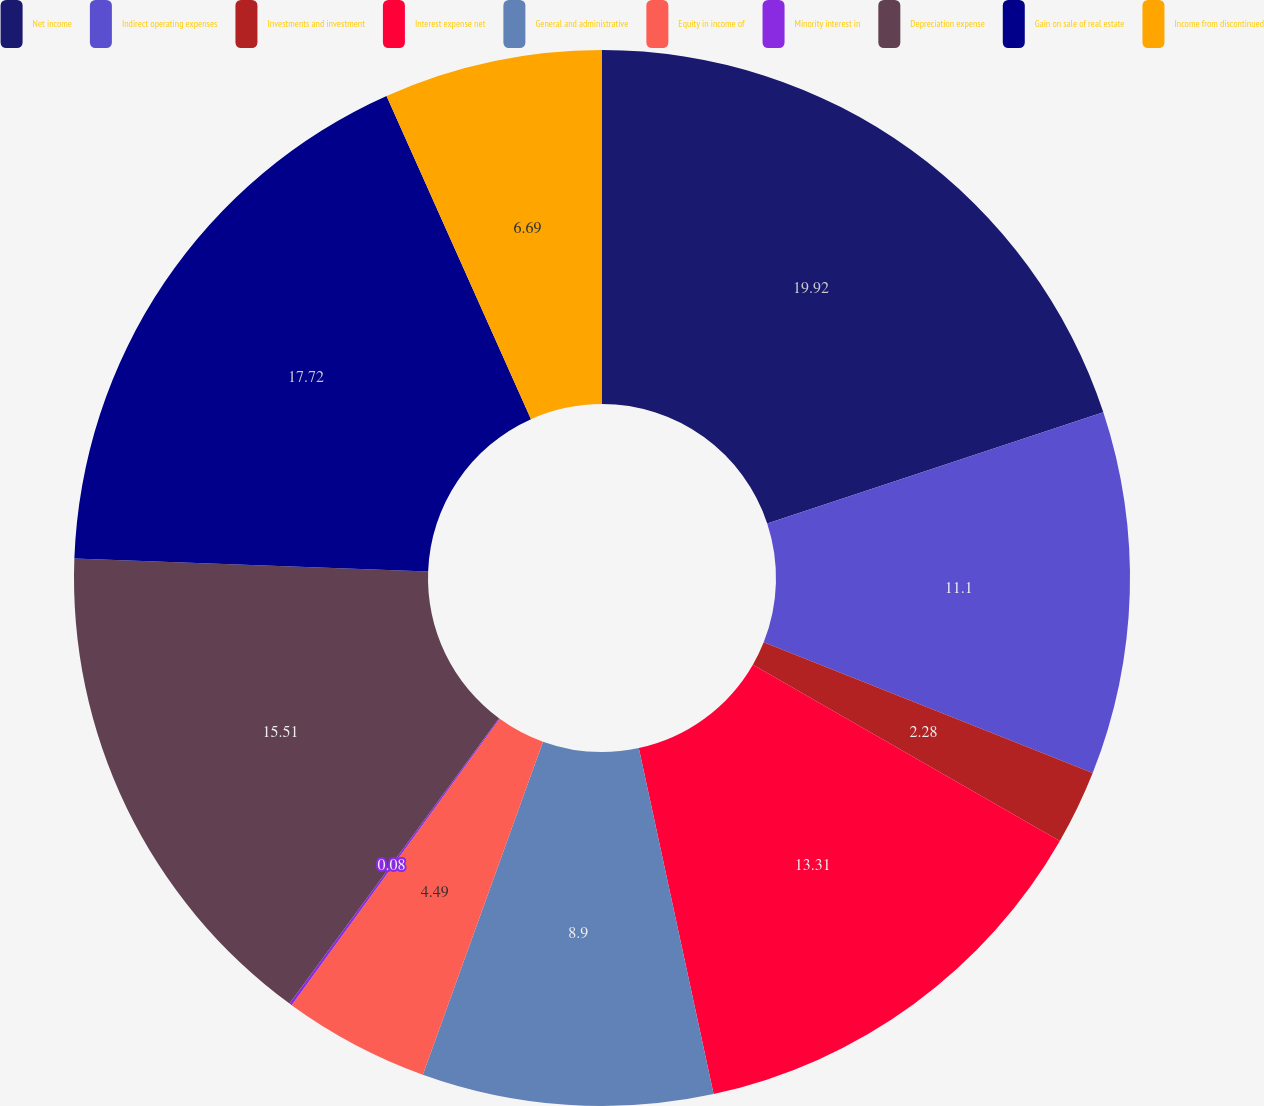Convert chart. <chart><loc_0><loc_0><loc_500><loc_500><pie_chart><fcel>Net income<fcel>Indirect operating expenses<fcel>Investments and investment<fcel>Interest expense net<fcel>General and administrative<fcel>Equity in income of<fcel>Minority interest in<fcel>Depreciation expense<fcel>Gain on sale of real estate<fcel>Income from discontinued<nl><fcel>19.92%<fcel>11.1%<fcel>2.28%<fcel>13.31%<fcel>8.9%<fcel>4.49%<fcel>0.08%<fcel>15.51%<fcel>17.72%<fcel>6.69%<nl></chart> 